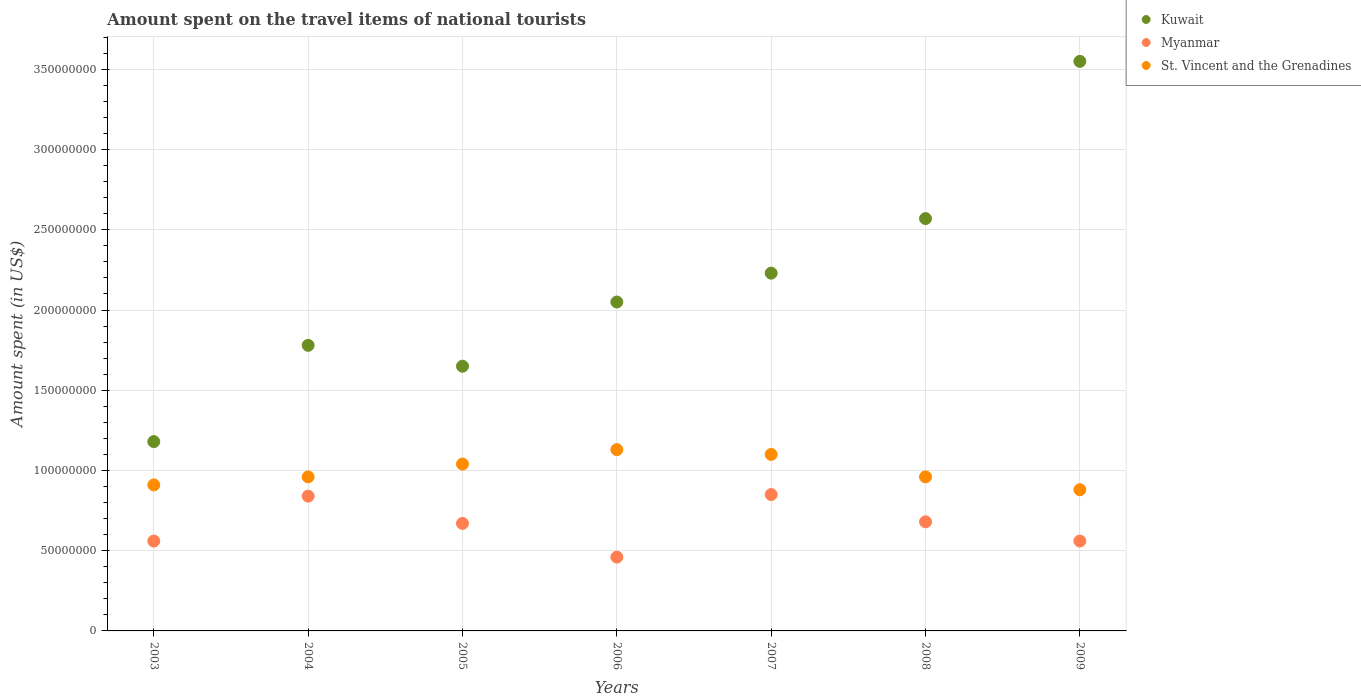How many different coloured dotlines are there?
Your response must be concise. 3. Is the number of dotlines equal to the number of legend labels?
Provide a succinct answer. Yes. What is the amount spent on the travel items of national tourists in St. Vincent and the Grenadines in 2003?
Your answer should be compact. 9.10e+07. Across all years, what is the maximum amount spent on the travel items of national tourists in Kuwait?
Offer a very short reply. 3.55e+08. Across all years, what is the minimum amount spent on the travel items of national tourists in Myanmar?
Ensure brevity in your answer.  4.60e+07. In which year was the amount spent on the travel items of national tourists in Kuwait minimum?
Ensure brevity in your answer.  2003. What is the total amount spent on the travel items of national tourists in St. Vincent and the Grenadines in the graph?
Provide a short and direct response. 6.98e+08. What is the difference between the amount spent on the travel items of national tourists in Myanmar in 2004 and that in 2006?
Give a very brief answer. 3.80e+07. What is the difference between the amount spent on the travel items of national tourists in St. Vincent and the Grenadines in 2009 and the amount spent on the travel items of national tourists in Kuwait in 2007?
Offer a terse response. -1.35e+08. What is the average amount spent on the travel items of national tourists in Kuwait per year?
Offer a very short reply. 2.14e+08. In the year 2008, what is the difference between the amount spent on the travel items of national tourists in Myanmar and amount spent on the travel items of national tourists in St. Vincent and the Grenadines?
Your answer should be compact. -2.80e+07. What is the ratio of the amount spent on the travel items of national tourists in St. Vincent and the Grenadines in 2004 to that in 2008?
Your response must be concise. 1. Is the amount spent on the travel items of national tourists in Kuwait in 2003 less than that in 2009?
Your response must be concise. Yes. What is the difference between the highest and the second highest amount spent on the travel items of national tourists in Kuwait?
Your answer should be very brief. 9.80e+07. What is the difference between the highest and the lowest amount spent on the travel items of national tourists in St. Vincent and the Grenadines?
Your response must be concise. 2.50e+07. In how many years, is the amount spent on the travel items of national tourists in Myanmar greater than the average amount spent on the travel items of national tourists in Myanmar taken over all years?
Your answer should be compact. 4. Is it the case that in every year, the sum of the amount spent on the travel items of national tourists in Kuwait and amount spent on the travel items of national tourists in St. Vincent and the Grenadines  is greater than the amount spent on the travel items of national tourists in Myanmar?
Provide a short and direct response. Yes. Does the amount spent on the travel items of national tourists in Kuwait monotonically increase over the years?
Offer a terse response. No. Is the amount spent on the travel items of national tourists in Kuwait strictly less than the amount spent on the travel items of national tourists in Myanmar over the years?
Give a very brief answer. No. How many dotlines are there?
Keep it short and to the point. 3. Are the values on the major ticks of Y-axis written in scientific E-notation?
Provide a short and direct response. No. Does the graph contain any zero values?
Give a very brief answer. No. Does the graph contain grids?
Your response must be concise. Yes. How are the legend labels stacked?
Your response must be concise. Vertical. What is the title of the graph?
Provide a short and direct response. Amount spent on the travel items of national tourists. What is the label or title of the Y-axis?
Provide a short and direct response. Amount spent (in US$). What is the Amount spent (in US$) of Kuwait in 2003?
Offer a very short reply. 1.18e+08. What is the Amount spent (in US$) in Myanmar in 2003?
Keep it short and to the point. 5.60e+07. What is the Amount spent (in US$) in St. Vincent and the Grenadines in 2003?
Make the answer very short. 9.10e+07. What is the Amount spent (in US$) of Kuwait in 2004?
Provide a succinct answer. 1.78e+08. What is the Amount spent (in US$) in Myanmar in 2004?
Your answer should be compact. 8.40e+07. What is the Amount spent (in US$) in St. Vincent and the Grenadines in 2004?
Offer a terse response. 9.60e+07. What is the Amount spent (in US$) in Kuwait in 2005?
Your response must be concise. 1.65e+08. What is the Amount spent (in US$) in Myanmar in 2005?
Keep it short and to the point. 6.70e+07. What is the Amount spent (in US$) in St. Vincent and the Grenadines in 2005?
Make the answer very short. 1.04e+08. What is the Amount spent (in US$) of Kuwait in 2006?
Your answer should be very brief. 2.05e+08. What is the Amount spent (in US$) in Myanmar in 2006?
Your answer should be compact. 4.60e+07. What is the Amount spent (in US$) in St. Vincent and the Grenadines in 2006?
Provide a succinct answer. 1.13e+08. What is the Amount spent (in US$) in Kuwait in 2007?
Your response must be concise. 2.23e+08. What is the Amount spent (in US$) in Myanmar in 2007?
Offer a terse response. 8.50e+07. What is the Amount spent (in US$) of St. Vincent and the Grenadines in 2007?
Your answer should be very brief. 1.10e+08. What is the Amount spent (in US$) in Kuwait in 2008?
Offer a terse response. 2.57e+08. What is the Amount spent (in US$) in Myanmar in 2008?
Offer a terse response. 6.80e+07. What is the Amount spent (in US$) of St. Vincent and the Grenadines in 2008?
Ensure brevity in your answer.  9.60e+07. What is the Amount spent (in US$) of Kuwait in 2009?
Provide a succinct answer. 3.55e+08. What is the Amount spent (in US$) in Myanmar in 2009?
Make the answer very short. 5.60e+07. What is the Amount spent (in US$) in St. Vincent and the Grenadines in 2009?
Make the answer very short. 8.80e+07. Across all years, what is the maximum Amount spent (in US$) in Kuwait?
Make the answer very short. 3.55e+08. Across all years, what is the maximum Amount spent (in US$) of Myanmar?
Provide a succinct answer. 8.50e+07. Across all years, what is the maximum Amount spent (in US$) in St. Vincent and the Grenadines?
Your response must be concise. 1.13e+08. Across all years, what is the minimum Amount spent (in US$) of Kuwait?
Your answer should be compact. 1.18e+08. Across all years, what is the minimum Amount spent (in US$) of Myanmar?
Ensure brevity in your answer.  4.60e+07. Across all years, what is the minimum Amount spent (in US$) in St. Vincent and the Grenadines?
Offer a terse response. 8.80e+07. What is the total Amount spent (in US$) of Kuwait in the graph?
Offer a terse response. 1.50e+09. What is the total Amount spent (in US$) in Myanmar in the graph?
Keep it short and to the point. 4.62e+08. What is the total Amount spent (in US$) in St. Vincent and the Grenadines in the graph?
Provide a short and direct response. 6.98e+08. What is the difference between the Amount spent (in US$) of Kuwait in 2003 and that in 2004?
Your answer should be compact. -6.00e+07. What is the difference between the Amount spent (in US$) of Myanmar in 2003 and that in 2004?
Your answer should be compact. -2.80e+07. What is the difference between the Amount spent (in US$) of St. Vincent and the Grenadines in 2003 and that in 2004?
Your answer should be very brief. -5.00e+06. What is the difference between the Amount spent (in US$) in Kuwait in 2003 and that in 2005?
Make the answer very short. -4.70e+07. What is the difference between the Amount spent (in US$) of Myanmar in 2003 and that in 2005?
Make the answer very short. -1.10e+07. What is the difference between the Amount spent (in US$) of St. Vincent and the Grenadines in 2003 and that in 2005?
Keep it short and to the point. -1.30e+07. What is the difference between the Amount spent (in US$) in Kuwait in 2003 and that in 2006?
Your answer should be compact. -8.70e+07. What is the difference between the Amount spent (in US$) of Myanmar in 2003 and that in 2006?
Your answer should be compact. 1.00e+07. What is the difference between the Amount spent (in US$) of St. Vincent and the Grenadines in 2003 and that in 2006?
Give a very brief answer. -2.20e+07. What is the difference between the Amount spent (in US$) of Kuwait in 2003 and that in 2007?
Ensure brevity in your answer.  -1.05e+08. What is the difference between the Amount spent (in US$) of Myanmar in 2003 and that in 2007?
Your answer should be very brief. -2.90e+07. What is the difference between the Amount spent (in US$) in St. Vincent and the Grenadines in 2003 and that in 2007?
Ensure brevity in your answer.  -1.90e+07. What is the difference between the Amount spent (in US$) of Kuwait in 2003 and that in 2008?
Offer a terse response. -1.39e+08. What is the difference between the Amount spent (in US$) of Myanmar in 2003 and that in 2008?
Your response must be concise. -1.20e+07. What is the difference between the Amount spent (in US$) in St. Vincent and the Grenadines in 2003 and that in 2008?
Keep it short and to the point. -5.00e+06. What is the difference between the Amount spent (in US$) in Kuwait in 2003 and that in 2009?
Provide a succinct answer. -2.37e+08. What is the difference between the Amount spent (in US$) in Myanmar in 2003 and that in 2009?
Your answer should be very brief. 0. What is the difference between the Amount spent (in US$) in Kuwait in 2004 and that in 2005?
Your answer should be very brief. 1.30e+07. What is the difference between the Amount spent (in US$) in Myanmar in 2004 and that in 2005?
Your response must be concise. 1.70e+07. What is the difference between the Amount spent (in US$) in St. Vincent and the Grenadines in 2004 and that in 2005?
Offer a very short reply. -8.00e+06. What is the difference between the Amount spent (in US$) of Kuwait in 2004 and that in 2006?
Your answer should be compact. -2.70e+07. What is the difference between the Amount spent (in US$) of Myanmar in 2004 and that in 2006?
Provide a succinct answer. 3.80e+07. What is the difference between the Amount spent (in US$) of St. Vincent and the Grenadines in 2004 and that in 2006?
Give a very brief answer. -1.70e+07. What is the difference between the Amount spent (in US$) of Kuwait in 2004 and that in 2007?
Your answer should be very brief. -4.50e+07. What is the difference between the Amount spent (in US$) of St. Vincent and the Grenadines in 2004 and that in 2007?
Your response must be concise. -1.40e+07. What is the difference between the Amount spent (in US$) of Kuwait in 2004 and that in 2008?
Provide a succinct answer. -7.90e+07. What is the difference between the Amount spent (in US$) in Myanmar in 2004 and that in 2008?
Make the answer very short. 1.60e+07. What is the difference between the Amount spent (in US$) in Kuwait in 2004 and that in 2009?
Provide a short and direct response. -1.77e+08. What is the difference between the Amount spent (in US$) in Myanmar in 2004 and that in 2009?
Offer a terse response. 2.80e+07. What is the difference between the Amount spent (in US$) of St. Vincent and the Grenadines in 2004 and that in 2009?
Your answer should be compact. 8.00e+06. What is the difference between the Amount spent (in US$) in Kuwait in 2005 and that in 2006?
Ensure brevity in your answer.  -4.00e+07. What is the difference between the Amount spent (in US$) of Myanmar in 2005 and that in 2006?
Offer a very short reply. 2.10e+07. What is the difference between the Amount spent (in US$) in St. Vincent and the Grenadines in 2005 and that in 2006?
Make the answer very short. -9.00e+06. What is the difference between the Amount spent (in US$) in Kuwait in 2005 and that in 2007?
Give a very brief answer. -5.80e+07. What is the difference between the Amount spent (in US$) of Myanmar in 2005 and that in 2007?
Keep it short and to the point. -1.80e+07. What is the difference between the Amount spent (in US$) in St. Vincent and the Grenadines in 2005 and that in 2007?
Your response must be concise. -6.00e+06. What is the difference between the Amount spent (in US$) of Kuwait in 2005 and that in 2008?
Your response must be concise. -9.20e+07. What is the difference between the Amount spent (in US$) in Myanmar in 2005 and that in 2008?
Your response must be concise. -1.00e+06. What is the difference between the Amount spent (in US$) of Kuwait in 2005 and that in 2009?
Offer a very short reply. -1.90e+08. What is the difference between the Amount spent (in US$) of Myanmar in 2005 and that in 2009?
Ensure brevity in your answer.  1.10e+07. What is the difference between the Amount spent (in US$) of St. Vincent and the Grenadines in 2005 and that in 2009?
Ensure brevity in your answer.  1.60e+07. What is the difference between the Amount spent (in US$) of Kuwait in 2006 and that in 2007?
Offer a very short reply. -1.80e+07. What is the difference between the Amount spent (in US$) of Myanmar in 2006 and that in 2007?
Give a very brief answer. -3.90e+07. What is the difference between the Amount spent (in US$) in Kuwait in 2006 and that in 2008?
Keep it short and to the point. -5.20e+07. What is the difference between the Amount spent (in US$) in Myanmar in 2006 and that in 2008?
Make the answer very short. -2.20e+07. What is the difference between the Amount spent (in US$) in St. Vincent and the Grenadines in 2006 and that in 2008?
Make the answer very short. 1.70e+07. What is the difference between the Amount spent (in US$) in Kuwait in 2006 and that in 2009?
Make the answer very short. -1.50e+08. What is the difference between the Amount spent (in US$) of Myanmar in 2006 and that in 2009?
Your answer should be compact. -1.00e+07. What is the difference between the Amount spent (in US$) of St. Vincent and the Grenadines in 2006 and that in 2009?
Your response must be concise. 2.50e+07. What is the difference between the Amount spent (in US$) of Kuwait in 2007 and that in 2008?
Offer a terse response. -3.40e+07. What is the difference between the Amount spent (in US$) in Myanmar in 2007 and that in 2008?
Your response must be concise. 1.70e+07. What is the difference between the Amount spent (in US$) in St. Vincent and the Grenadines in 2007 and that in 2008?
Provide a short and direct response. 1.40e+07. What is the difference between the Amount spent (in US$) in Kuwait in 2007 and that in 2009?
Keep it short and to the point. -1.32e+08. What is the difference between the Amount spent (in US$) of Myanmar in 2007 and that in 2009?
Provide a short and direct response. 2.90e+07. What is the difference between the Amount spent (in US$) of St. Vincent and the Grenadines in 2007 and that in 2009?
Offer a very short reply. 2.20e+07. What is the difference between the Amount spent (in US$) of Kuwait in 2008 and that in 2009?
Offer a very short reply. -9.80e+07. What is the difference between the Amount spent (in US$) of St. Vincent and the Grenadines in 2008 and that in 2009?
Your answer should be very brief. 8.00e+06. What is the difference between the Amount spent (in US$) in Kuwait in 2003 and the Amount spent (in US$) in Myanmar in 2004?
Make the answer very short. 3.40e+07. What is the difference between the Amount spent (in US$) in Kuwait in 2003 and the Amount spent (in US$) in St. Vincent and the Grenadines in 2004?
Your answer should be compact. 2.20e+07. What is the difference between the Amount spent (in US$) of Myanmar in 2003 and the Amount spent (in US$) of St. Vincent and the Grenadines in 2004?
Make the answer very short. -4.00e+07. What is the difference between the Amount spent (in US$) in Kuwait in 2003 and the Amount spent (in US$) in Myanmar in 2005?
Give a very brief answer. 5.10e+07. What is the difference between the Amount spent (in US$) of Kuwait in 2003 and the Amount spent (in US$) of St. Vincent and the Grenadines in 2005?
Your answer should be very brief. 1.40e+07. What is the difference between the Amount spent (in US$) in Myanmar in 2003 and the Amount spent (in US$) in St. Vincent and the Grenadines in 2005?
Your answer should be very brief. -4.80e+07. What is the difference between the Amount spent (in US$) in Kuwait in 2003 and the Amount spent (in US$) in Myanmar in 2006?
Give a very brief answer. 7.20e+07. What is the difference between the Amount spent (in US$) of Myanmar in 2003 and the Amount spent (in US$) of St. Vincent and the Grenadines in 2006?
Give a very brief answer. -5.70e+07. What is the difference between the Amount spent (in US$) in Kuwait in 2003 and the Amount spent (in US$) in Myanmar in 2007?
Give a very brief answer. 3.30e+07. What is the difference between the Amount spent (in US$) of Myanmar in 2003 and the Amount spent (in US$) of St. Vincent and the Grenadines in 2007?
Keep it short and to the point. -5.40e+07. What is the difference between the Amount spent (in US$) in Kuwait in 2003 and the Amount spent (in US$) in Myanmar in 2008?
Ensure brevity in your answer.  5.00e+07. What is the difference between the Amount spent (in US$) in Kuwait in 2003 and the Amount spent (in US$) in St. Vincent and the Grenadines in 2008?
Provide a short and direct response. 2.20e+07. What is the difference between the Amount spent (in US$) of Myanmar in 2003 and the Amount spent (in US$) of St. Vincent and the Grenadines in 2008?
Your response must be concise. -4.00e+07. What is the difference between the Amount spent (in US$) of Kuwait in 2003 and the Amount spent (in US$) of Myanmar in 2009?
Your response must be concise. 6.20e+07. What is the difference between the Amount spent (in US$) in Kuwait in 2003 and the Amount spent (in US$) in St. Vincent and the Grenadines in 2009?
Your answer should be compact. 3.00e+07. What is the difference between the Amount spent (in US$) of Myanmar in 2003 and the Amount spent (in US$) of St. Vincent and the Grenadines in 2009?
Provide a succinct answer. -3.20e+07. What is the difference between the Amount spent (in US$) of Kuwait in 2004 and the Amount spent (in US$) of Myanmar in 2005?
Give a very brief answer. 1.11e+08. What is the difference between the Amount spent (in US$) of Kuwait in 2004 and the Amount spent (in US$) of St. Vincent and the Grenadines in 2005?
Keep it short and to the point. 7.40e+07. What is the difference between the Amount spent (in US$) of Myanmar in 2004 and the Amount spent (in US$) of St. Vincent and the Grenadines in 2005?
Your answer should be compact. -2.00e+07. What is the difference between the Amount spent (in US$) of Kuwait in 2004 and the Amount spent (in US$) of Myanmar in 2006?
Keep it short and to the point. 1.32e+08. What is the difference between the Amount spent (in US$) of Kuwait in 2004 and the Amount spent (in US$) of St. Vincent and the Grenadines in 2006?
Keep it short and to the point. 6.50e+07. What is the difference between the Amount spent (in US$) in Myanmar in 2004 and the Amount spent (in US$) in St. Vincent and the Grenadines in 2006?
Your answer should be very brief. -2.90e+07. What is the difference between the Amount spent (in US$) in Kuwait in 2004 and the Amount spent (in US$) in Myanmar in 2007?
Your answer should be compact. 9.30e+07. What is the difference between the Amount spent (in US$) of Kuwait in 2004 and the Amount spent (in US$) of St. Vincent and the Grenadines in 2007?
Give a very brief answer. 6.80e+07. What is the difference between the Amount spent (in US$) in Myanmar in 2004 and the Amount spent (in US$) in St. Vincent and the Grenadines in 2007?
Provide a succinct answer. -2.60e+07. What is the difference between the Amount spent (in US$) of Kuwait in 2004 and the Amount spent (in US$) of Myanmar in 2008?
Keep it short and to the point. 1.10e+08. What is the difference between the Amount spent (in US$) of Kuwait in 2004 and the Amount spent (in US$) of St. Vincent and the Grenadines in 2008?
Offer a very short reply. 8.20e+07. What is the difference between the Amount spent (in US$) of Myanmar in 2004 and the Amount spent (in US$) of St. Vincent and the Grenadines in 2008?
Keep it short and to the point. -1.20e+07. What is the difference between the Amount spent (in US$) of Kuwait in 2004 and the Amount spent (in US$) of Myanmar in 2009?
Offer a very short reply. 1.22e+08. What is the difference between the Amount spent (in US$) in Kuwait in 2004 and the Amount spent (in US$) in St. Vincent and the Grenadines in 2009?
Provide a short and direct response. 9.00e+07. What is the difference between the Amount spent (in US$) of Kuwait in 2005 and the Amount spent (in US$) of Myanmar in 2006?
Provide a succinct answer. 1.19e+08. What is the difference between the Amount spent (in US$) of Kuwait in 2005 and the Amount spent (in US$) of St. Vincent and the Grenadines in 2006?
Offer a very short reply. 5.20e+07. What is the difference between the Amount spent (in US$) in Myanmar in 2005 and the Amount spent (in US$) in St. Vincent and the Grenadines in 2006?
Make the answer very short. -4.60e+07. What is the difference between the Amount spent (in US$) of Kuwait in 2005 and the Amount spent (in US$) of Myanmar in 2007?
Your answer should be very brief. 8.00e+07. What is the difference between the Amount spent (in US$) of Kuwait in 2005 and the Amount spent (in US$) of St. Vincent and the Grenadines in 2007?
Provide a succinct answer. 5.50e+07. What is the difference between the Amount spent (in US$) in Myanmar in 2005 and the Amount spent (in US$) in St. Vincent and the Grenadines in 2007?
Your answer should be compact. -4.30e+07. What is the difference between the Amount spent (in US$) in Kuwait in 2005 and the Amount spent (in US$) in Myanmar in 2008?
Your response must be concise. 9.70e+07. What is the difference between the Amount spent (in US$) in Kuwait in 2005 and the Amount spent (in US$) in St. Vincent and the Grenadines in 2008?
Keep it short and to the point. 6.90e+07. What is the difference between the Amount spent (in US$) of Myanmar in 2005 and the Amount spent (in US$) of St. Vincent and the Grenadines in 2008?
Provide a succinct answer. -2.90e+07. What is the difference between the Amount spent (in US$) in Kuwait in 2005 and the Amount spent (in US$) in Myanmar in 2009?
Ensure brevity in your answer.  1.09e+08. What is the difference between the Amount spent (in US$) in Kuwait in 2005 and the Amount spent (in US$) in St. Vincent and the Grenadines in 2009?
Offer a very short reply. 7.70e+07. What is the difference between the Amount spent (in US$) in Myanmar in 2005 and the Amount spent (in US$) in St. Vincent and the Grenadines in 2009?
Offer a terse response. -2.10e+07. What is the difference between the Amount spent (in US$) in Kuwait in 2006 and the Amount spent (in US$) in Myanmar in 2007?
Provide a short and direct response. 1.20e+08. What is the difference between the Amount spent (in US$) in Kuwait in 2006 and the Amount spent (in US$) in St. Vincent and the Grenadines in 2007?
Give a very brief answer. 9.50e+07. What is the difference between the Amount spent (in US$) of Myanmar in 2006 and the Amount spent (in US$) of St. Vincent and the Grenadines in 2007?
Provide a short and direct response. -6.40e+07. What is the difference between the Amount spent (in US$) in Kuwait in 2006 and the Amount spent (in US$) in Myanmar in 2008?
Make the answer very short. 1.37e+08. What is the difference between the Amount spent (in US$) of Kuwait in 2006 and the Amount spent (in US$) of St. Vincent and the Grenadines in 2008?
Provide a succinct answer. 1.09e+08. What is the difference between the Amount spent (in US$) of Myanmar in 2006 and the Amount spent (in US$) of St. Vincent and the Grenadines in 2008?
Your answer should be compact. -5.00e+07. What is the difference between the Amount spent (in US$) of Kuwait in 2006 and the Amount spent (in US$) of Myanmar in 2009?
Keep it short and to the point. 1.49e+08. What is the difference between the Amount spent (in US$) in Kuwait in 2006 and the Amount spent (in US$) in St. Vincent and the Grenadines in 2009?
Offer a terse response. 1.17e+08. What is the difference between the Amount spent (in US$) of Myanmar in 2006 and the Amount spent (in US$) of St. Vincent and the Grenadines in 2009?
Your response must be concise. -4.20e+07. What is the difference between the Amount spent (in US$) of Kuwait in 2007 and the Amount spent (in US$) of Myanmar in 2008?
Ensure brevity in your answer.  1.55e+08. What is the difference between the Amount spent (in US$) in Kuwait in 2007 and the Amount spent (in US$) in St. Vincent and the Grenadines in 2008?
Ensure brevity in your answer.  1.27e+08. What is the difference between the Amount spent (in US$) of Myanmar in 2007 and the Amount spent (in US$) of St. Vincent and the Grenadines in 2008?
Provide a short and direct response. -1.10e+07. What is the difference between the Amount spent (in US$) of Kuwait in 2007 and the Amount spent (in US$) of Myanmar in 2009?
Offer a very short reply. 1.67e+08. What is the difference between the Amount spent (in US$) in Kuwait in 2007 and the Amount spent (in US$) in St. Vincent and the Grenadines in 2009?
Your response must be concise. 1.35e+08. What is the difference between the Amount spent (in US$) of Kuwait in 2008 and the Amount spent (in US$) of Myanmar in 2009?
Your response must be concise. 2.01e+08. What is the difference between the Amount spent (in US$) in Kuwait in 2008 and the Amount spent (in US$) in St. Vincent and the Grenadines in 2009?
Your response must be concise. 1.69e+08. What is the difference between the Amount spent (in US$) in Myanmar in 2008 and the Amount spent (in US$) in St. Vincent and the Grenadines in 2009?
Your answer should be compact. -2.00e+07. What is the average Amount spent (in US$) of Kuwait per year?
Provide a short and direct response. 2.14e+08. What is the average Amount spent (in US$) in Myanmar per year?
Ensure brevity in your answer.  6.60e+07. What is the average Amount spent (in US$) in St. Vincent and the Grenadines per year?
Provide a short and direct response. 9.97e+07. In the year 2003, what is the difference between the Amount spent (in US$) in Kuwait and Amount spent (in US$) in Myanmar?
Ensure brevity in your answer.  6.20e+07. In the year 2003, what is the difference between the Amount spent (in US$) in Kuwait and Amount spent (in US$) in St. Vincent and the Grenadines?
Provide a succinct answer. 2.70e+07. In the year 2003, what is the difference between the Amount spent (in US$) of Myanmar and Amount spent (in US$) of St. Vincent and the Grenadines?
Offer a very short reply. -3.50e+07. In the year 2004, what is the difference between the Amount spent (in US$) in Kuwait and Amount spent (in US$) in Myanmar?
Ensure brevity in your answer.  9.40e+07. In the year 2004, what is the difference between the Amount spent (in US$) in Kuwait and Amount spent (in US$) in St. Vincent and the Grenadines?
Provide a succinct answer. 8.20e+07. In the year 2004, what is the difference between the Amount spent (in US$) in Myanmar and Amount spent (in US$) in St. Vincent and the Grenadines?
Keep it short and to the point. -1.20e+07. In the year 2005, what is the difference between the Amount spent (in US$) in Kuwait and Amount spent (in US$) in Myanmar?
Ensure brevity in your answer.  9.80e+07. In the year 2005, what is the difference between the Amount spent (in US$) of Kuwait and Amount spent (in US$) of St. Vincent and the Grenadines?
Make the answer very short. 6.10e+07. In the year 2005, what is the difference between the Amount spent (in US$) in Myanmar and Amount spent (in US$) in St. Vincent and the Grenadines?
Offer a terse response. -3.70e+07. In the year 2006, what is the difference between the Amount spent (in US$) in Kuwait and Amount spent (in US$) in Myanmar?
Your answer should be very brief. 1.59e+08. In the year 2006, what is the difference between the Amount spent (in US$) in Kuwait and Amount spent (in US$) in St. Vincent and the Grenadines?
Offer a terse response. 9.20e+07. In the year 2006, what is the difference between the Amount spent (in US$) in Myanmar and Amount spent (in US$) in St. Vincent and the Grenadines?
Your answer should be very brief. -6.70e+07. In the year 2007, what is the difference between the Amount spent (in US$) of Kuwait and Amount spent (in US$) of Myanmar?
Offer a very short reply. 1.38e+08. In the year 2007, what is the difference between the Amount spent (in US$) of Kuwait and Amount spent (in US$) of St. Vincent and the Grenadines?
Give a very brief answer. 1.13e+08. In the year 2007, what is the difference between the Amount spent (in US$) of Myanmar and Amount spent (in US$) of St. Vincent and the Grenadines?
Your answer should be very brief. -2.50e+07. In the year 2008, what is the difference between the Amount spent (in US$) in Kuwait and Amount spent (in US$) in Myanmar?
Keep it short and to the point. 1.89e+08. In the year 2008, what is the difference between the Amount spent (in US$) of Kuwait and Amount spent (in US$) of St. Vincent and the Grenadines?
Give a very brief answer. 1.61e+08. In the year 2008, what is the difference between the Amount spent (in US$) of Myanmar and Amount spent (in US$) of St. Vincent and the Grenadines?
Keep it short and to the point. -2.80e+07. In the year 2009, what is the difference between the Amount spent (in US$) in Kuwait and Amount spent (in US$) in Myanmar?
Your response must be concise. 2.99e+08. In the year 2009, what is the difference between the Amount spent (in US$) of Kuwait and Amount spent (in US$) of St. Vincent and the Grenadines?
Offer a very short reply. 2.67e+08. In the year 2009, what is the difference between the Amount spent (in US$) in Myanmar and Amount spent (in US$) in St. Vincent and the Grenadines?
Make the answer very short. -3.20e+07. What is the ratio of the Amount spent (in US$) of Kuwait in 2003 to that in 2004?
Give a very brief answer. 0.66. What is the ratio of the Amount spent (in US$) of Myanmar in 2003 to that in 2004?
Ensure brevity in your answer.  0.67. What is the ratio of the Amount spent (in US$) in St. Vincent and the Grenadines in 2003 to that in 2004?
Offer a terse response. 0.95. What is the ratio of the Amount spent (in US$) in Kuwait in 2003 to that in 2005?
Provide a succinct answer. 0.72. What is the ratio of the Amount spent (in US$) in Myanmar in 2003 to that in 2005?
Provide a succinct answer. 0.84. What is the ratio of the Amount spent (in US$) in Kuwait in 2003 to that in 2006?
Provide a short and direct response. 0.58. What is the ratio of the Amount spent (in US$) of Myanmar in 2003 to that in 2006?
Your response must be concise. 1.22. What is the ratio of the Amount spent (in US$) in St. Vincent and the Grenadines in 2003 to that in 2006?
Keep it short and to the point. 0.81. What is the ratio of the Amount spent (in US$) of Kuwait in 2003 to that in 2007?
Keep it short and to the point. 0.53. What is the ratio of the Amount spent (in US$) of Myanmar in 2003 to that in 2007?
Ensure brevity in your answer.  0.66. What is the ratio of the Amount spent (in US$) in St. Vincent and the Grenadines in 2003 to that in 2007?
Provide a short and direct response. 0.83. What is the ratio of the Amount spent (in US$) of Kuwait in 2003 to that in 2008?
Offer a terse response. 0.46. What is the ratio of the Amount spent (in US$) in Myanmar in 2003 to that in 2008?
Keep it short and to the point. 0.82. What is the ratio of the Amount spent (in US$) of St. Vincent and the Grenadines in 2003 to that in 2008?
Provide a short and direct response. 0.95. What is the ratio of the Amount spent (in US$) of Kuwait in 2003 to that in 2009?
Your answer should be compact. 0.33. What is the ratio of the Amount spent (in US$) in Myanmar in 2003 to that in 2009?
Your response must be concise. 1. What is the ratio of the Amount spent (in US$) of St. Vincent and the Grenadines in 2003 to that in 2009?
Your answer should be very brief. 1.03. What is the ratio of the Amount spent (in US$) of Kuwait in 2004 to that in 2005?
Make the answer very short. 1.08. What is the ratio of the Amount spent (in US$) of Myanmar in 2004 to that in 2005?
Your answer should be very brief. 1.25. What is the ratio of the Amount spent (in US$) in St. Vincent and the Grenadines in 2004 to that in 2005?
Provide a succinct answer. 0.92. What is the ratio of the Amount spent (in US$) of Kuwait in 2004 to that in 2006?
Make the answer very short. 0.87. What is the ratio of the Amount spent (in US$) of Myanmar in 2004 to that in 2006?
Keep it short and to the point. 1.83. What is the ratio of the Amount spent (in US$) in St. Vincent and the Grenadines in 2004 to that in 2006?
Ensure brevity in your answer.  0.85. What is the ratio of the Amount spent (in US$) of Kuwait in 2004 to that in 2007?
Your response must be concise. 0.8. What is the ratio of the Amount spent (in US$) in St. Vincent and the Grenadines in 2004 to that in 2007?
Offer a very short reply. 0.87. What is the ratio of the Amount spent (in US$) in Kuwait in 2004 to that in 2008?
Provide a short and direct response. 0.69. What is the ratio of the Amount spent (in US$) of Myanmar in 2004 to that in 2008?
Offer a very short reply. 1.24. What is the ratio of the Amount spent (in US$) of Kuwait in 2004 to that in 2009?
Your response must be concise. 0.5. What is the ratio of the Amount spent (in US$) in Kuwait in 2005 to that in 2006?
Provide a short and direct response. 0.8. What is the ratio of the Amount spent (in US$) of Myanmar in 2005 to that in 2006?
Offer a very short reply. 1.46. What is the ratio of the Amount spent (in US$) of St. Vincent and the Grenadines in 2005 to that in 2006?
Offer a terse response. 0.92. What is the ratio of the Amount spent (in US$) in Kuwait in 2005 to that in 2007?
Ensure brevity in your answer.  0.74. What is the ratio of the Amount spent (in US$) in Myanmar in 2005 to that in 2007?
Give a very brief answer. 0.79. What is the ratio of the Amount spent (in US$) in St. Vincent and the Grenadines in 2005 to that in 2007?
Provide a short and direct response. 0.95. What is the ratio of the Amount spent (in US$) in Kuwait in 2005 to that in 2008?
Provide a short and direct response. 0.64. What is the ratio of the Amount spent (in US$) in Kuwait in 2005 to that in 2009?
Provide a short and direct response. 0.46. What is the ratio of the Amount spent (in US$) in Myanmar in 2005 to that in 2009?
Make the answer very short. 1.2. What is the ratio of the Amount spent (in US$) of St. Vincent and the Grenadines in 2005 to that in 2009?
Make the answer very short. 1.18. What is the ratio of the Amount spent (in US$) of Kuwait in 2006 to that in 2007?
Give a very brief answer. 0.92. What is the ratio of the Amount spent (in US$) in Myanmar in 2006 to that in 2007?
Keep it short and to the point. 0.54. What is the ratio of the Amount spent (in US$) of St. Vincent and the Grenadines in 2006 to that in 2007?
Offer a very short reply. 1.03. What is the ratio of the Amount spent (in US$) in Kuwait in 2006 to that in 2008?
Your answer should be compact. 0.8. What is the ratio of the Amount spent (in US$) in Myanmar in 2006 to that in 2008?
Make the answer very short. 0.68. What is the ratio of the Amount spent (in US$) of St. Vincent and the Grenadines in 2006 to that in 2008?
Offer a very short reply. 1.18. What is the ratio of the Amount spent (in US$) in Kuwait in 2006 to that in 2009?
Make the answer very short. 0.58. What is the ratio of the Amount spent (in US$) in Myanmar in 2006 to that in 2009?
Make the answer very short. 0.82. What is the ratio of the Amount spent (in US$) of St. Vincent and the Grenadines in 2006 to that in 2009?
Give a very brief answer. 1.28. What is the ratio of the Amount spent (in US$) of Kuwait in 2007 to that in 2008?
Give a very brief answer. 0.87. What is the ratio of the Amount spent (in US$) of Myanmar in 2007 to that in 2008?
Give a very brief answer. 1.25. What is the ratio of the Amount spent (in US$) in St. Vincent and the Grenadines in 2007 to that in 2008?
Offer a very short reply. 1.15. What is the ratio of the Amount spent (in US$) in Kuwait in 2007 to that in 2009?
Offer a terse response. 0.63. What is the ratio of the Amount spent (in US$) of Myanmar in 2007 to that in 2009?
Provide a succinct answer. 1.52. What is the ratio of the Amount spent (in US$) of Kuwait in 2008 to that in 2009?
Provide a succinct answer. 0.72. What is the ratio of the Amount spent (in US$) of Myanmar in 2008 to that in 2009?
Provide a succinct answer. 1.21. What is the difference between the highest and the second highest Amount spent (in US$) in Kuwait?
Offer a very short reply. 9.80e+07. What is the difference between the highest and the second highest Amount spent (in US$) of St. Vincent and the Grenadines?
Your answer should be compact. 3.00e+06. What is the difference between the highest and the lowest Amount spent (in US$) of Kuwait?
Offer a very short reply. 2.37e+08. What is the difference between the highest and the lowest Amount spent (in US$) of Myanmar?
Offer a terse response. 3.90e+07. What is the difference between the highest and the lowest Amount spent (in US$) in St. Vincent and the Grenadines?
Your answer should be compact. 2.50e+07. 